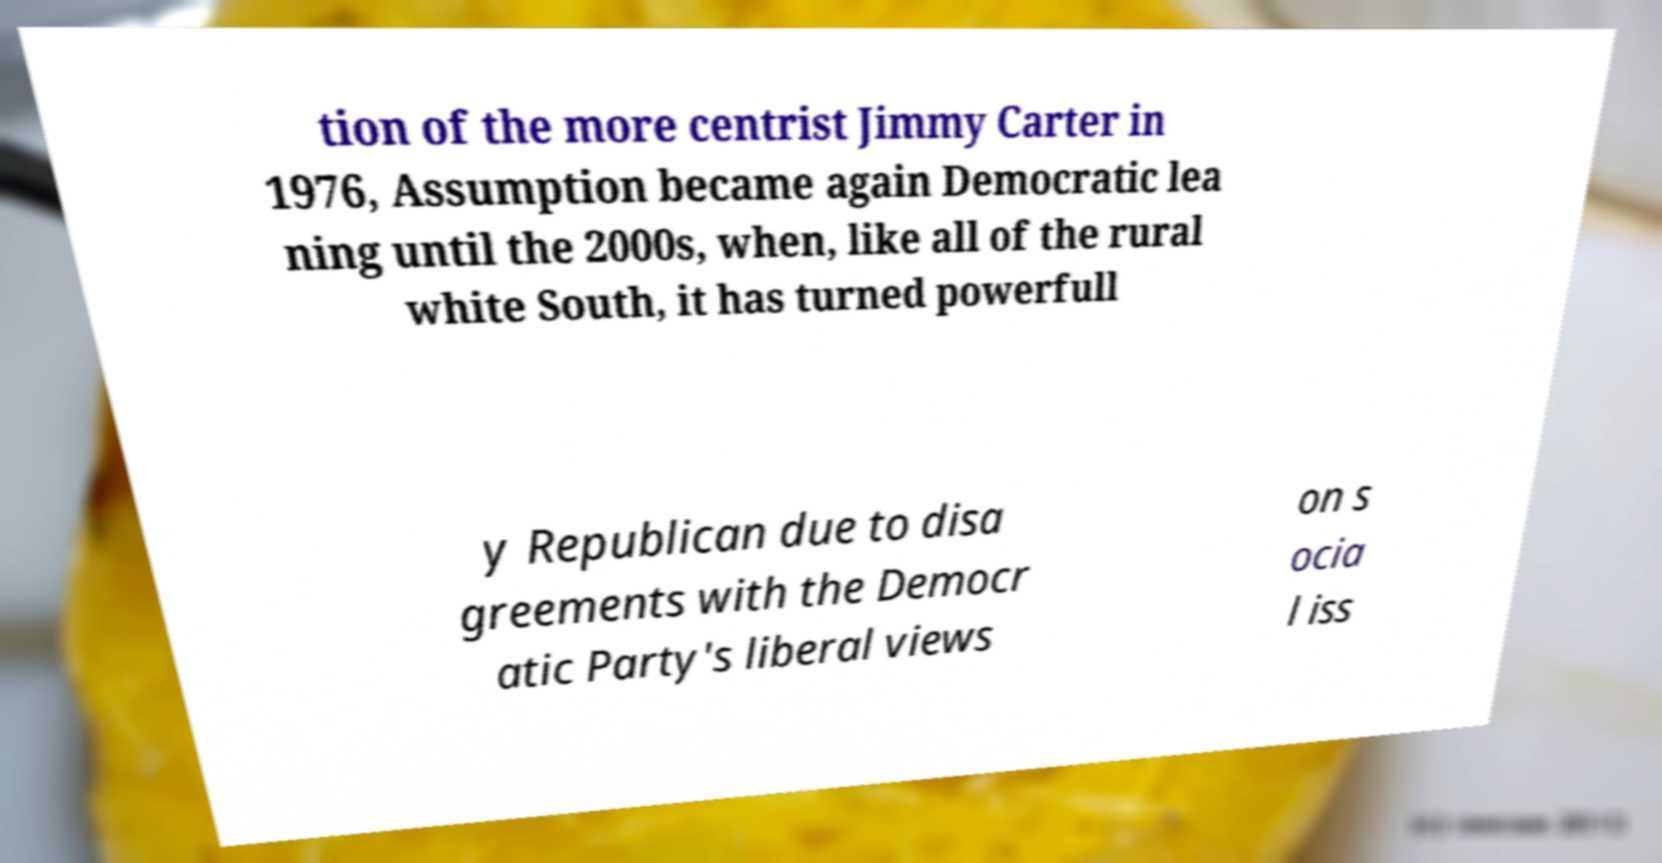Could you extract and type out the text from this image? tion of the more centrist Jimmy Carter in 1976, Assumption became again Democratic lea ning until the 2000s, when, like all of the rural white South, it has turned powerfull y Republican due to disa greements with the Democr atic Party's liberal views on s ocia l iss 